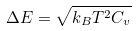Convert formula to latex. <formula><loc_0><loc_0><loc_500><loc_500>\Delta E = \sqrt { k _ { B } T ^ { 2 } C _ { v } }</formula> 